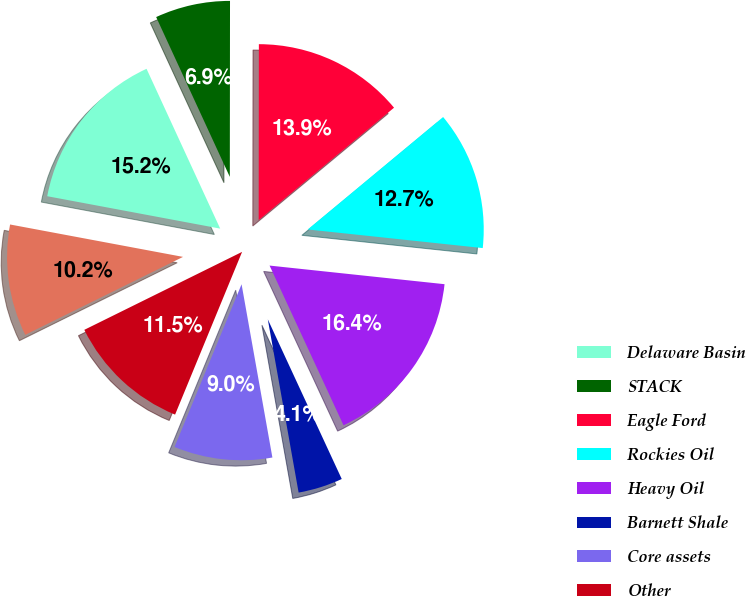Convert chart to OTSL. <chart><loc_0><loc_0><loc_500><loc_500><pie_chart><fcel>Delaware Basin<fcel>STACK<fcel>Eagle Ford<fcel>Rockies Oil<fcel>Heavy Oil<fcel>Barnett Shale<fcel>Core assets<fcel>Other<fcel>Total<nl><fcel>15.18%<fcel>6.89%<fcel>13.95%<fcel>12.72%<fcel>16.41%<fcel>4.1%<fcel>9.02%<fcel>11.48%<fcel>10.25%<nl></chart> 